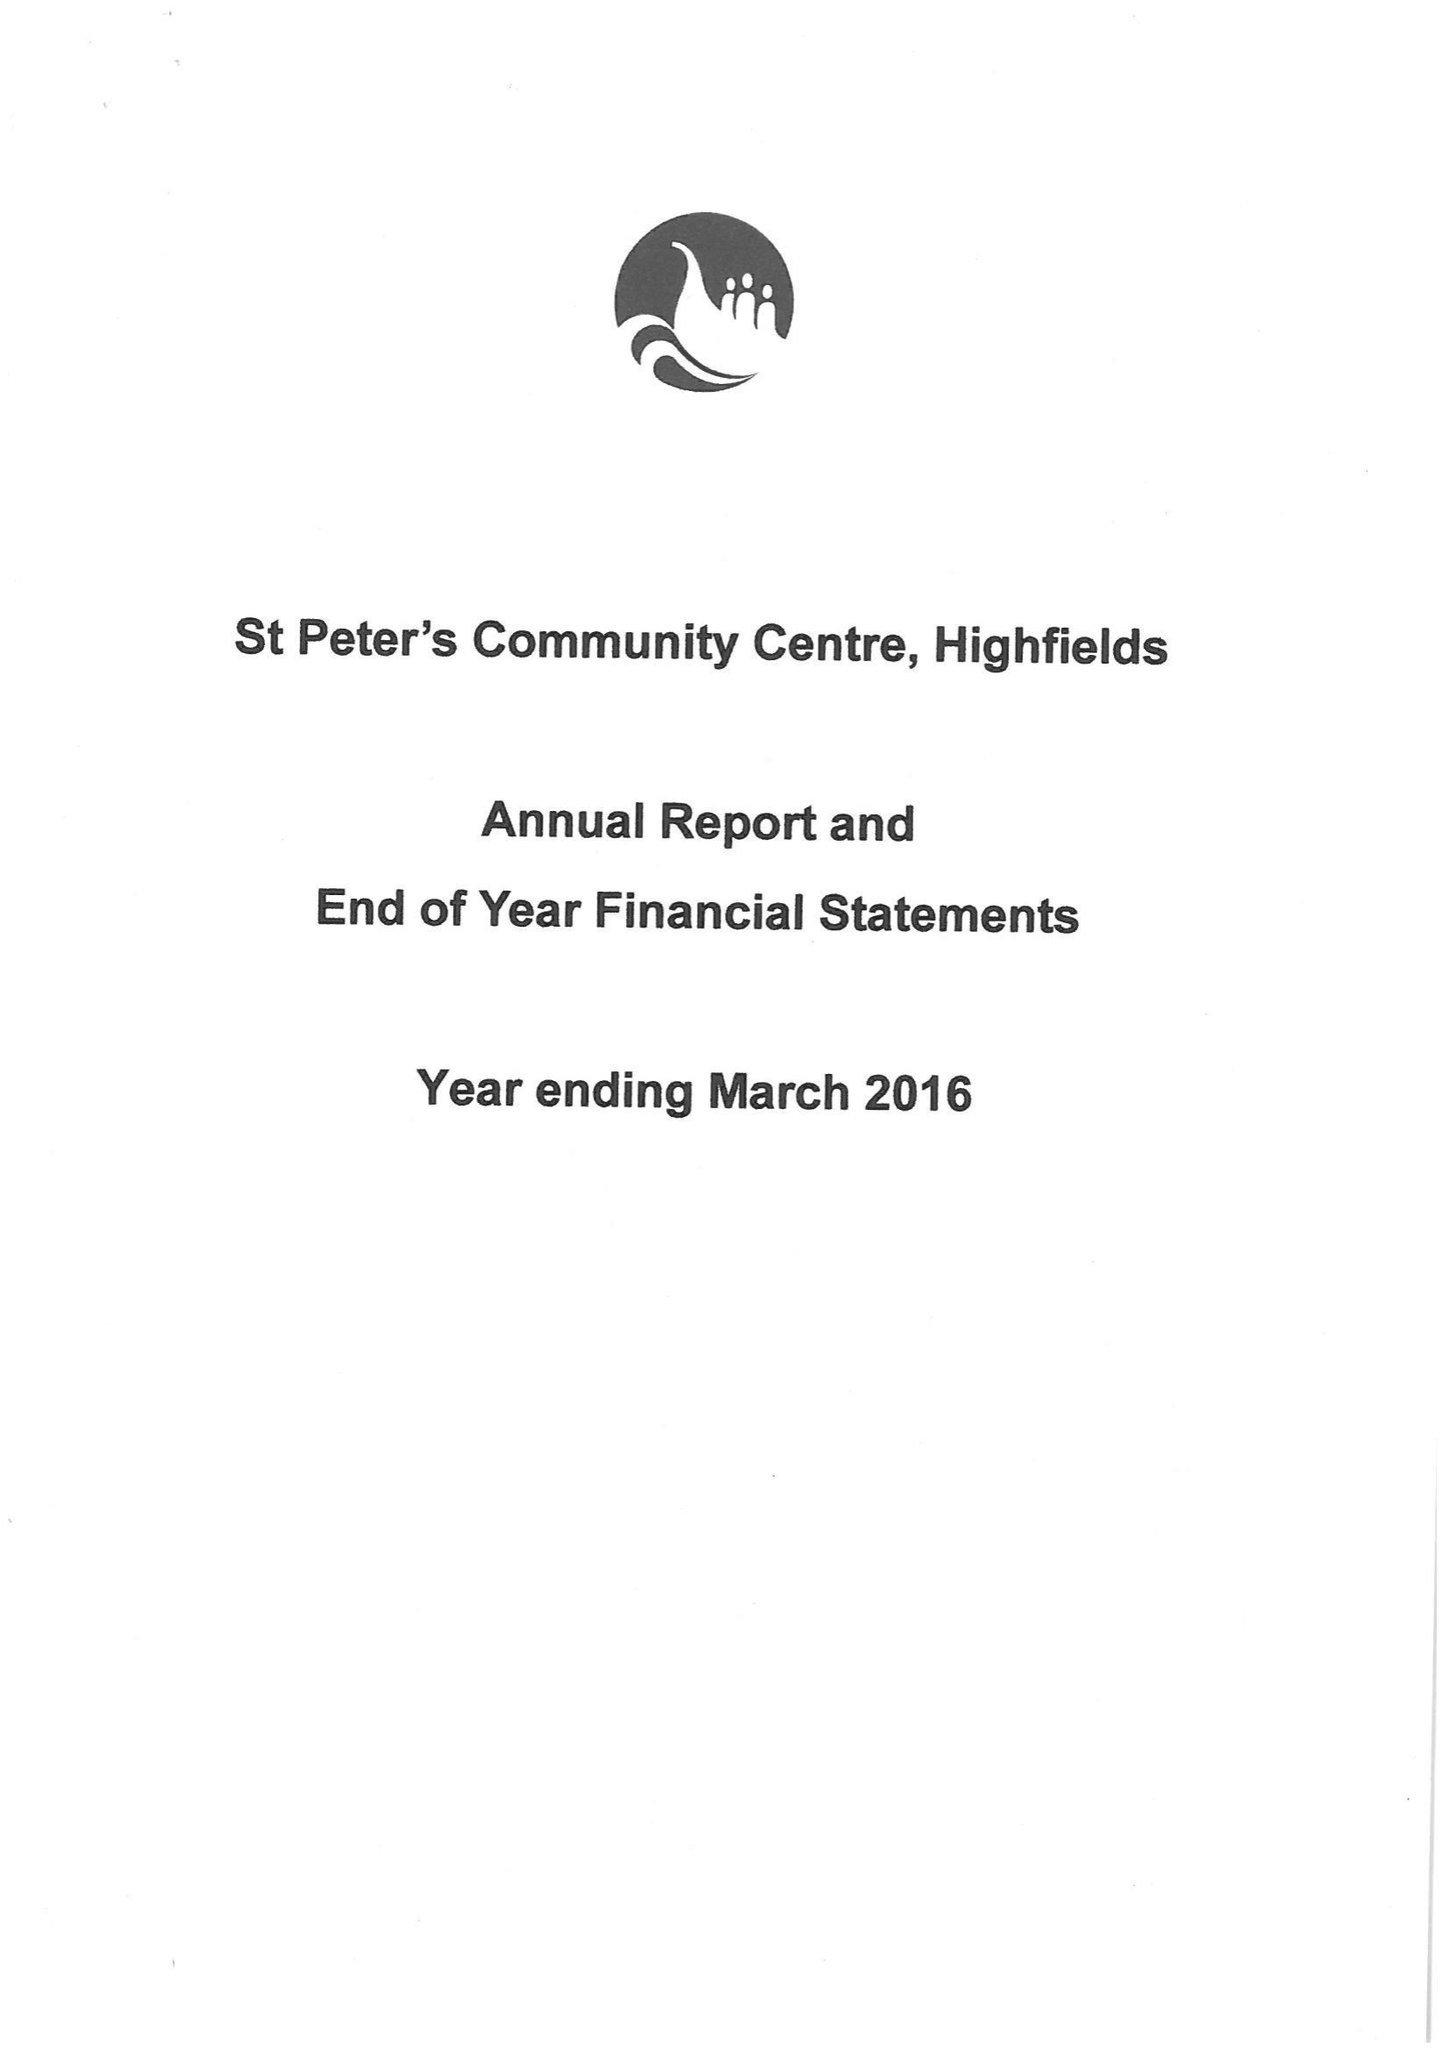What is the value for the charity_name?
Answer the question using a single word or phrase. St Peter's Community Centre 